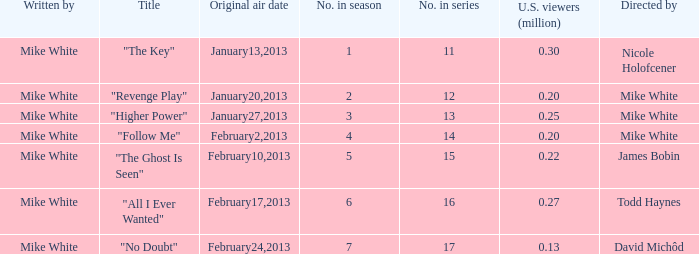What is the name of the episode directed by james bobin "The Ghost Is Seen". 